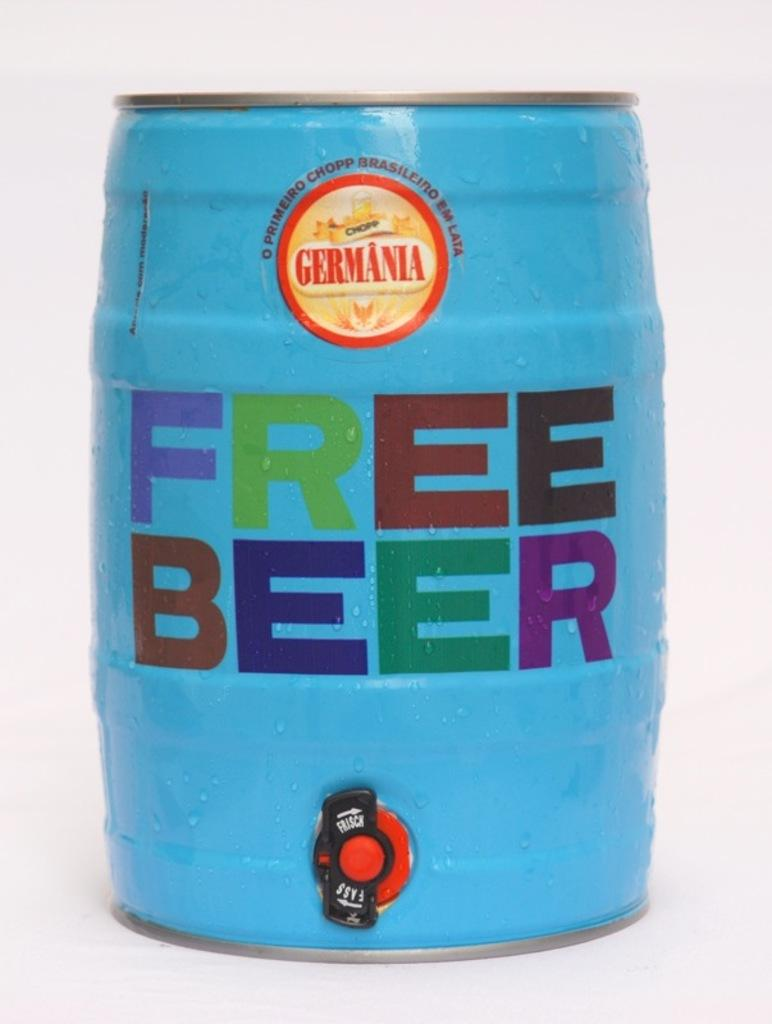<image>
Write a terse but informative summary of the picture. A blue barrel that says "free beer" has a red tap at the bottom. 